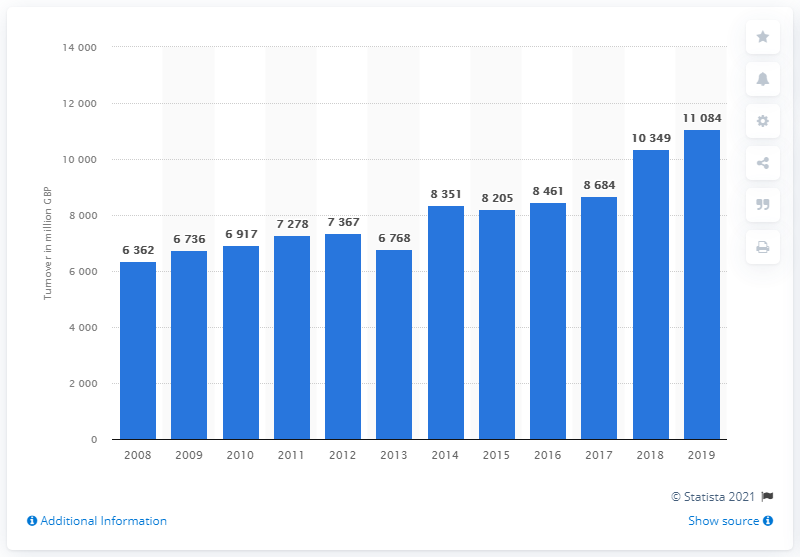Indicate a few pertinent items in this graphic. The annual turnover of the retail sale of household and personal appliances in the UK from 2008 to 2019 was 11,084. 